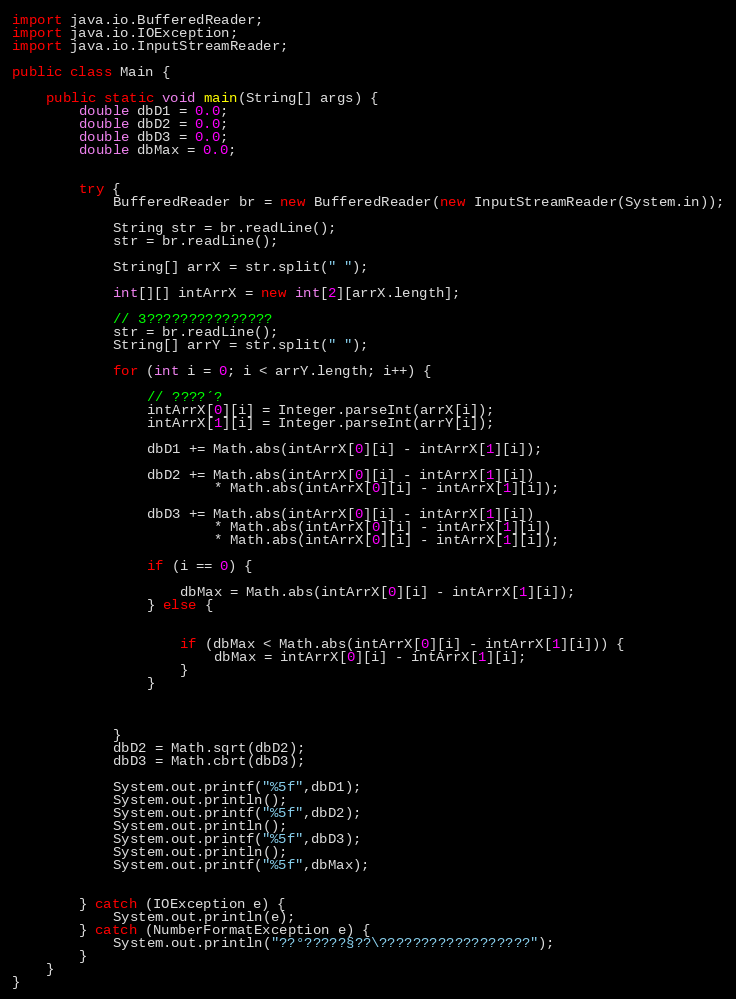<code> <loc_0><loc_0><loc_500><loc_500><_Java_>import java.io.BufferedReader;
import java.io.IOException;
import java.io.InputStreamReader;

public class Main {

	public static void main(String[] args) {
		double dbD1 = 0.0;
		double dbD2 = 0.0;
		double dbD3 = 0.0;
		double dbMax = 0.0;


		try {
			BufferedReader br = new BufferedReader(new InputStreamReader(System.in));

			String str = br.readLine();
			str = br.readLine();

			String[] arrX = str.split(" ");

			int[][] intArrX = new int[2][arrX.length];

			// 3???????????????
			str = br.readLine();
			String[] arrY = str.split(" ");

			for (int i = 0; i < arrY.length; i++) {

				// ????´?
				intArrX[0][i] = Integer.parseInt(arrX[i]);
				intArrX[1][i] = Integer.parseInt(arrY[i]);

				dbD1 += Math.abs(intArrX[0][i] - intArrX[1][i]);

				dbD2 += Math.abs(intArrX[0][i] - intArrX[1][i])
						* Math.abs(intArrX[0][i] - intArrX[1][i]);

				dbD3 += Math.abs(intArrX[0][i] - intArrX[1][i])
						* Math.abs(intArrX[0][i] - intArrX[1][i])
						* Math.abs(intArrX[0][i] - intArrX[1][i]);

				if (i == 0) {

					dbMax = Math.abs(intArrX[0][i] - intArrX[1][i]);
				} else {


					if (dbMax < Math.abs(intArrX[0][i] - intArrX[1][i])) {
						dbMax = intArrX[0][i] - intArrX[1][i];
					}
				}



			}
			dbD2 = Math.sqrt(dbD2);
			dbD3 = Math.cbrt(dbD3);

			System.out.printf("%5f",dbD1);
			System.out.println();
			System.out.printf("%5f",dbD2);
			System.out.println();
			System.out.printf("%5f",dbD3);
			System.out.println();
			System.out.printf("%5f",dbMax);


		} catch (IOException e) {
			System.out.println(e);
		} catch (NumberFormatException e) {
			System.out.println("??°?????§??\??????????????????");
		}
	}
}</code> 